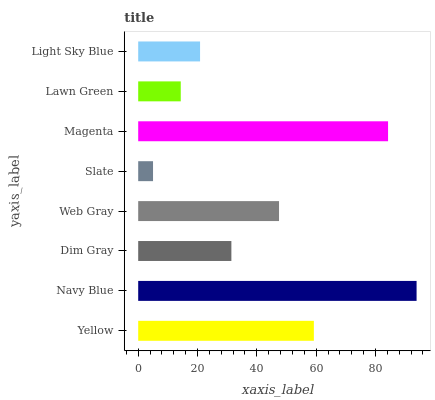Is Slate the minimum?
Answer yes or no. Yes. Is Navy Blue the maximum?
Answer yes or no. Yes. Is Dim Gray the minimum?
Answer yes or no. No. Is Dim Gray the maximum?
Answer yes or no. No. Is Navy Blue greater than Dim Gray?
Answer yes or no. Yes. Is Dim Gray less than Navy Blue?
Answer yes or no. Yes. Is Dim Gray greater than Navy Blue?
Answer yes or no. No. Is Navy Blue less than Dim Gray?
Answer yes or no. No. Is Web Gray the high median?
Answer yes or no. Yes. Is Dim Gray the low median?
Answer yes or no. Yes. Is Lawn Green the high median?
Answer yes or no. No. Is Lawn Green the low median?
Answer yes or no. No. 